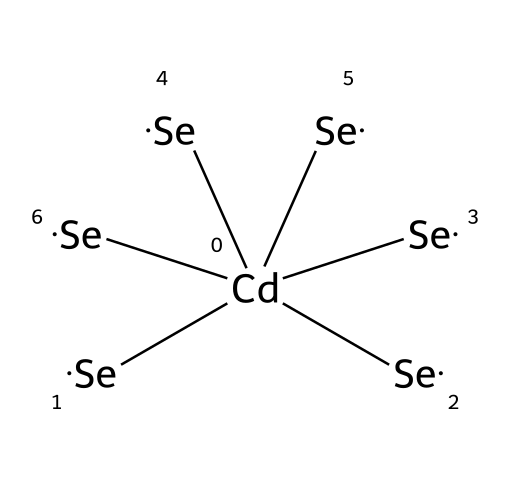What is the central atom in this quantum dot structure? The chemical structure indicates that cadmium (Cd) is the central atom, as it is represented at the center of the SMILES notation.
Answer: cadmium How many selenium atoms are connected to the cadmium atom? The SMILES notation shows six instances of selenium (Se) atoms surrounding the central cadmium atom, indicating that six selenium atoms are connected.
Answer: six What type of chemical strategy might be indicated by the arrangement of atoms in this quantum dot? The structure suggests a core-shell strategy commonly used in quantum dot synthesis, as the central cadmium atom is surrounded by multiple selenium atoms, enhancing optical and electronic properties.
Answer: core-shell What is the primary application of cadmium selenide quantum dots? Cadmium selenide quantum dots are primarily used in displays and electronic applications for their unique optical properties and color purity, which aids in improving resolution.
Answer: displays What does the presence of cadmium in this quantum dot indicate about toxicity? The presence of cadmium suggests potential toxicity, as cadmium compounds are known to be hazardous to health and the environment, leading to concerns about their use.
Answer: toxicity What characteristic property of cadmium selenide quantum dots makes them useful in historical document authentication? The characteristic property of narrow size distribution in cadmium selenide quantum dots allows for precise photoluminescence, which can be used in authentication by providing identifiable spectral signatures.
Answer: photoluminescence How many total atoms are present in the cadmium selenide quantum dot structure? The structure consists of one cadmium atom and six selenium atoms, totaling seven atoms in the quantum dot structure.
Answer: seven 